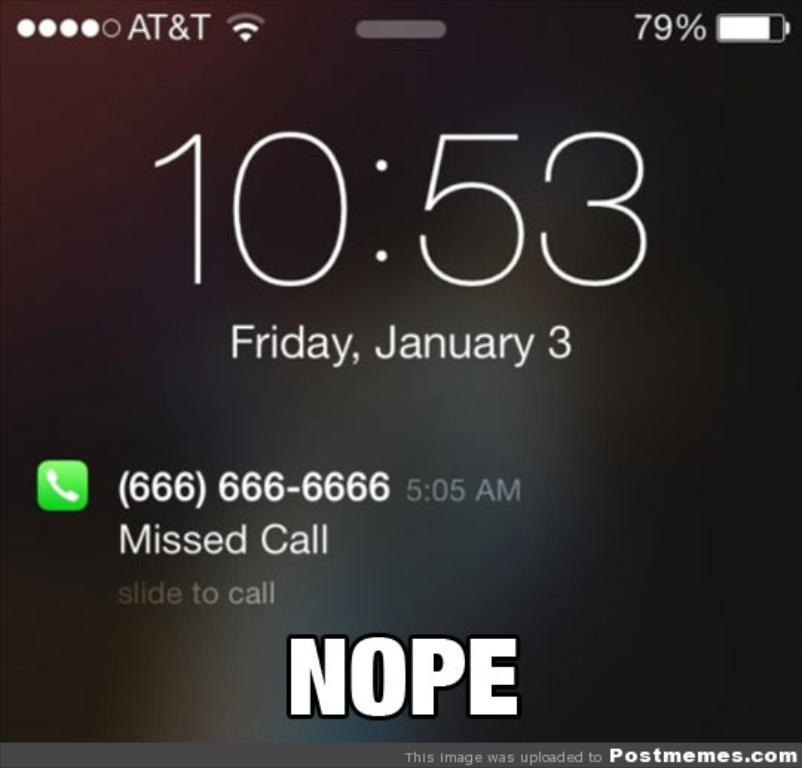<image>
Write a terse but informative summary of the picture. time is 10:53 friday january 3 on a phone screenshot 